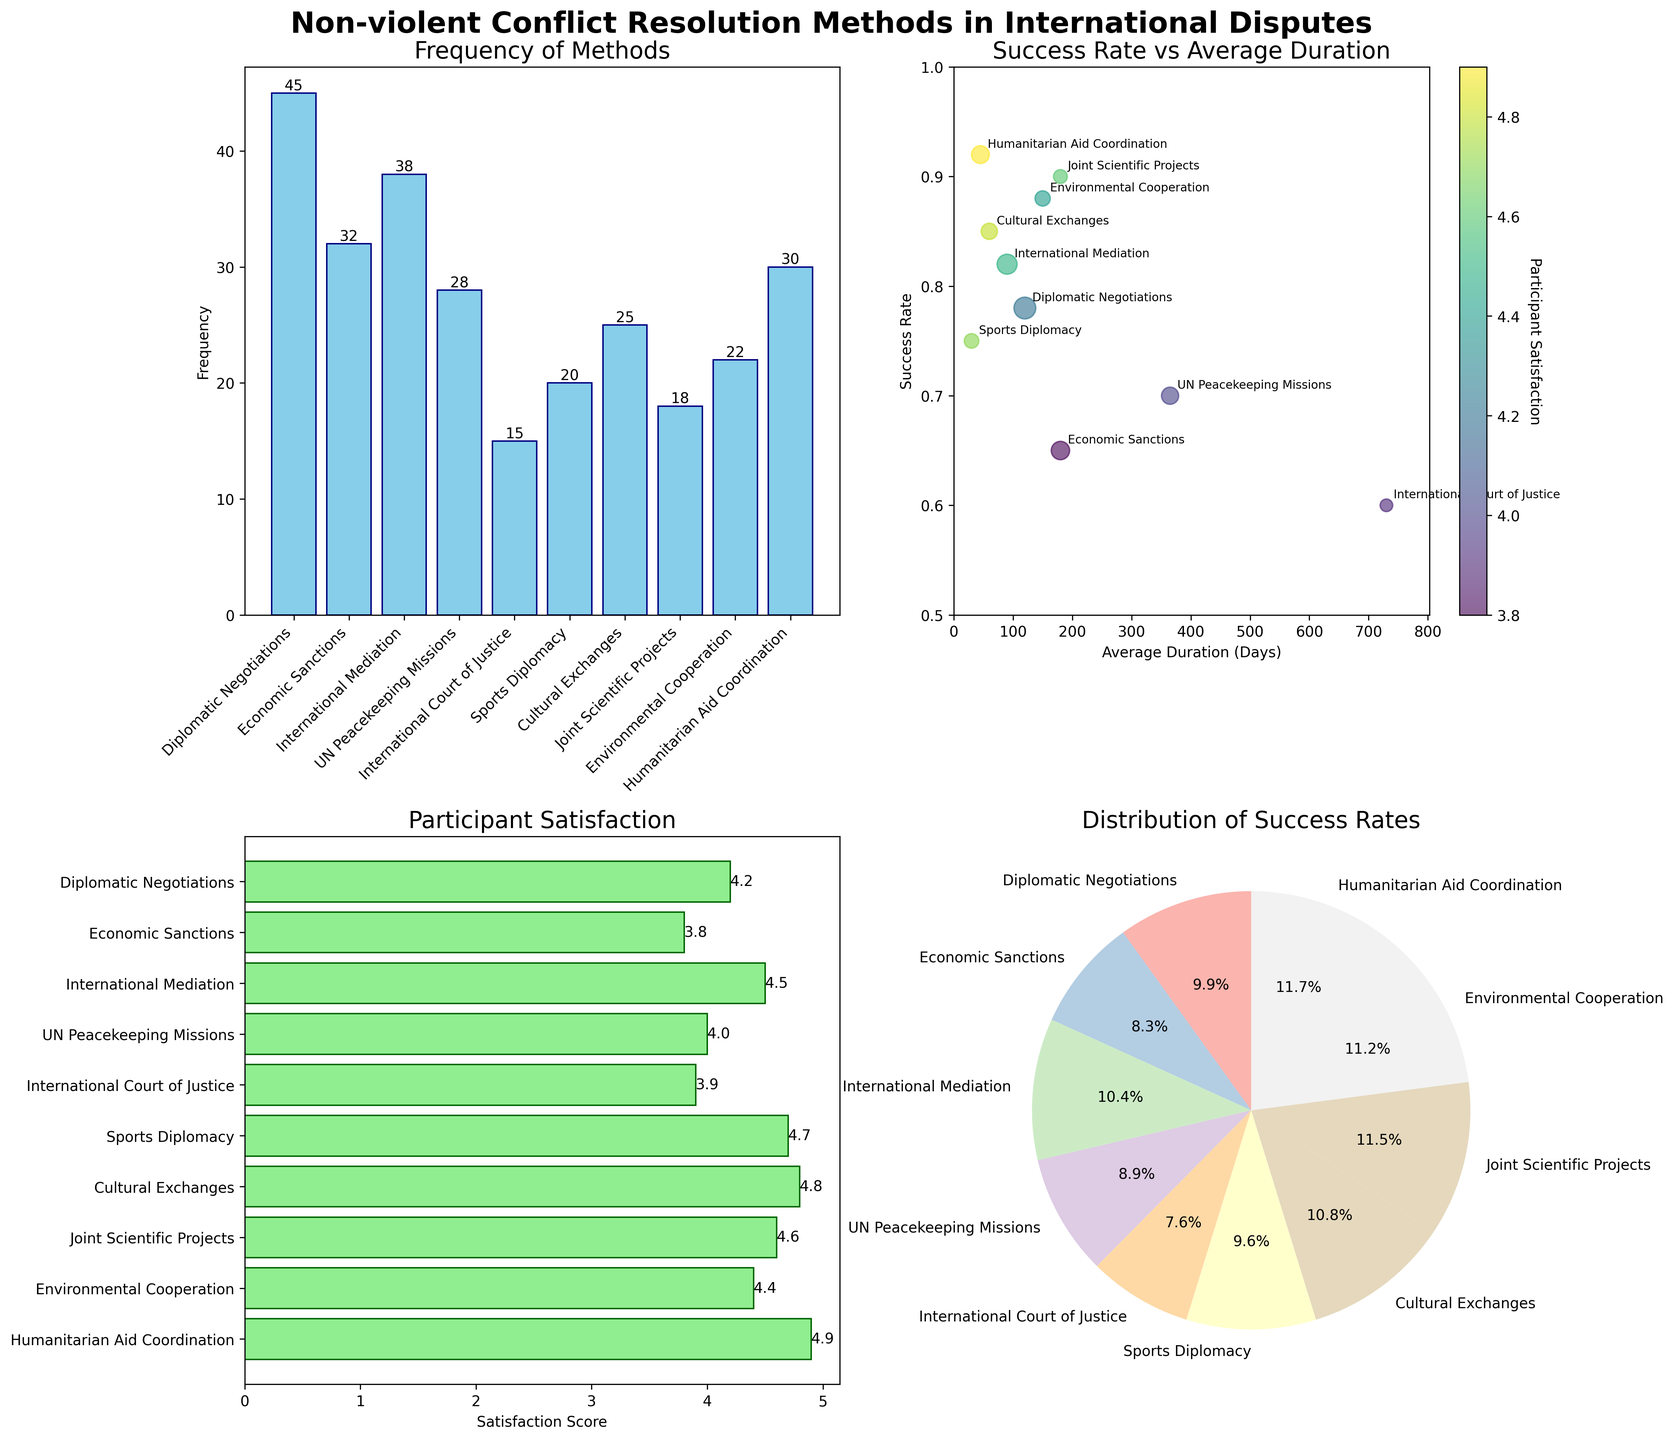What is the frequency of International Mediation used as a non-violent conflict resolution method? The bar plot titled 'Frequency of Methods' shows the frequency of International Mediation as 38
Answer: 38 Which method has the highest participant satisfaction score? From the horizontal bar plot titled 'Participant Satisfaction', the method with the highest satisfaction score is Humanitarian Aid Coordination at 4.9
Answer: Humanitarian Aid Coordination What is the relationship between the Success Rate and Average Duration for Diplomatic Negotiations? In the scatter plot titled 'Success Rate vs Average Duration', Diplomatic Negotiations is annotated at approximately 120 days with a success rate around 0.78
Answer: 120 days, 0.78 success rate Which method accounts for the smallest slice in the Success Rate distribution pie chart? The pie chart titled 'Distribution of Success Rates' indicates that the International Court of Justice has the smallest slice with a success rate of 0.60
Answer: International Court of Justice Based on the rank of participant satisfaction, which method ranks just below Sports Diplomacy? The horizontal bar plot for 'Participant Satisfaction' shows sports diplomacy at 4.7, followed by Joint Scientific Projects at 4.6
Answer: Joint Scientific Projects What is the sum of the frequencies of the two methods with the highest success rates? The top two methods by success rate are Humanitarian Aid Coordination (0.92) and Joint Scientific Projects (0.90). Their frequencies are 30 and 18 respectively, summing to 48
Answer: 48 Which method with an average duration greater than 150 days has the highest success rate? From the scatter plot, among those with average duration greater than 150 days (Economic Sanctions, UN Peacekeeping Missions, Joint Scientific Projects, Environmental Cooperation), Environmental Cooperation has the highest success rate of 0.88
Answer: Environmental Cooperation Among all methods, which two have the closest success rates? From the pie chart, the closest success rates are Diplomatic Negotiations (0.78) and Sports Diplomacy (0.75)
Answer: Diplomatic Negotiations and Sports Diplomacy How does participant satisfaction vary with success rates in the scatter plot? The scatter plot shows that generally, methods with higher success rates also have higher participant satisfaction scores, with notable points being Humanitarian Aid Coordination (0.92, 4.9) and Cultural Exchanges (0.85, 4.8)
Answer: Higher success rates generally correlate with higher participant satisfaction 